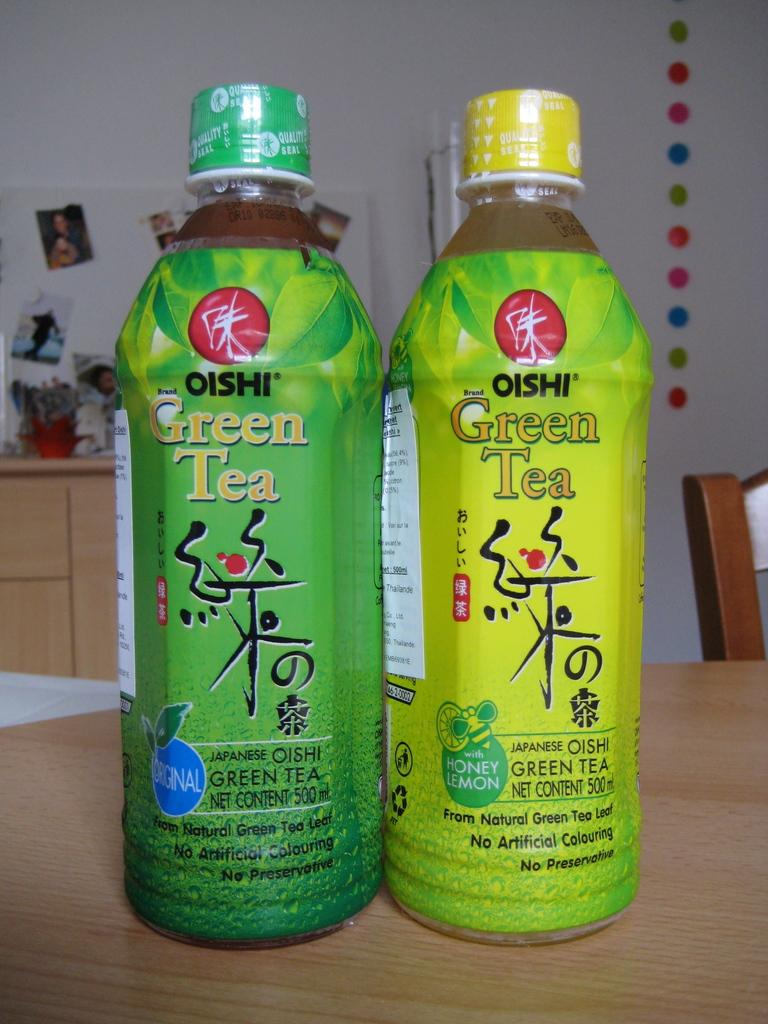How many bottles are on the table in the image? There are two bottles on the table in the image. What can be seen in the background of the image? There is a wall and a chair in the background of the image. What is attached to the wall in the image? There are photos attached to the wall in the image. What type of steel is used to construct the board in the image? There is no board or steel present in the image. What advice can be seen written on the wall in the image? There is no advice written on the wall in the image; only photos are attached to the wall. 